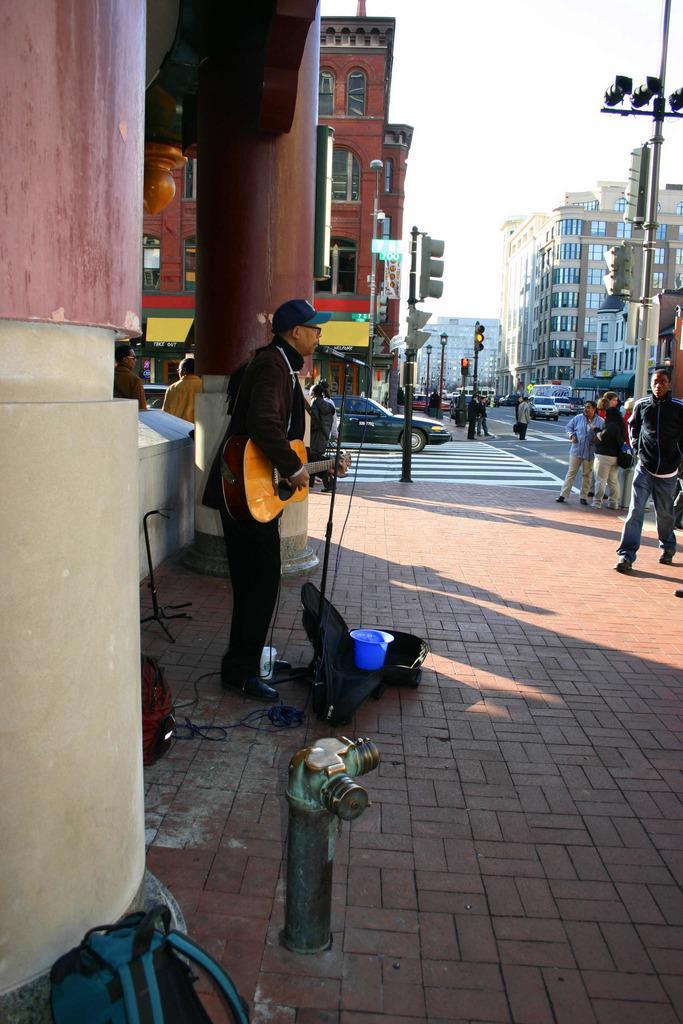Describe this image in one or two sentences. In this image we can see pillars, buildings, signal light poles, people, sky, pedestrians and vehicles. Front this person is playing a guitar. On the floor there is a guitar bag, stand and things. In-front of this pillar there is a hydrant.   